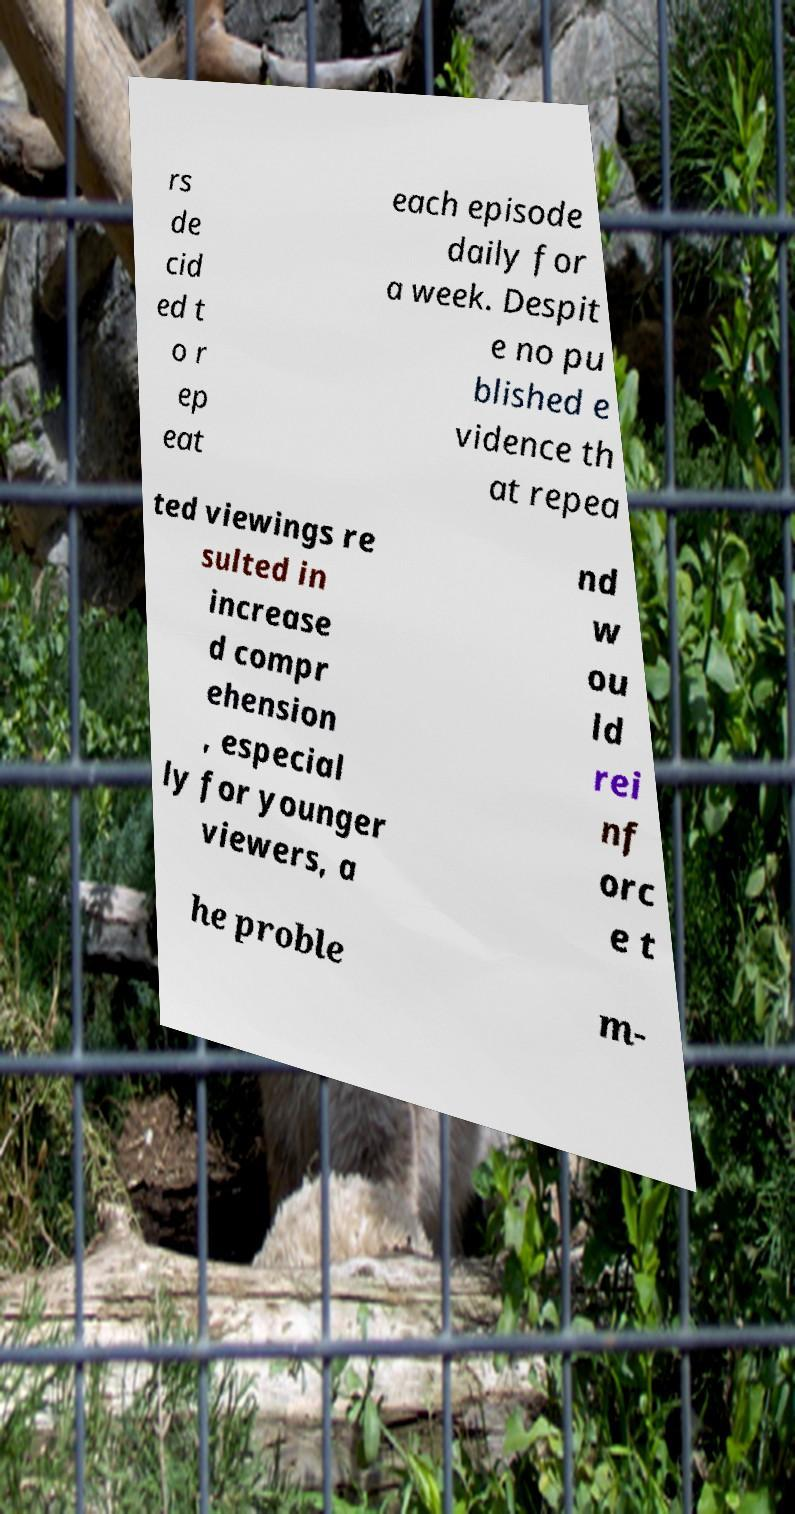Could you extract and type out the text from this image? rs de cid ed t o r ep eat each episode daily for a week. Despit e no pu blished e vidence th at repea ted viewings re sulted in increase d compr ehension , especial ly for younger viewers, a nd w ou ld rei nf orc e t he proble m- 